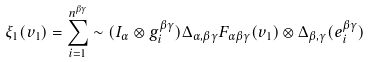Convert formula to latex. <formula><loc_0><loc_0><loc_500><loc_500>\xi _ { 1 } ( v _ { 1 } ) = \sum _ { i = 1 } ^ { n ^ { \beta \gamma } } \sim ( I _ { \alpha } \otimes g _ { i } ^ { \beta \gamma } ) \Delta _ { \alpha , \beta \gamma } F _ { \alpha \beta \gamma } ( v _ { 1 } ) \otimes \Delta _ { \beta , \gamma } ( e _ { i } ^ { \beta \gamma } )</formula> 